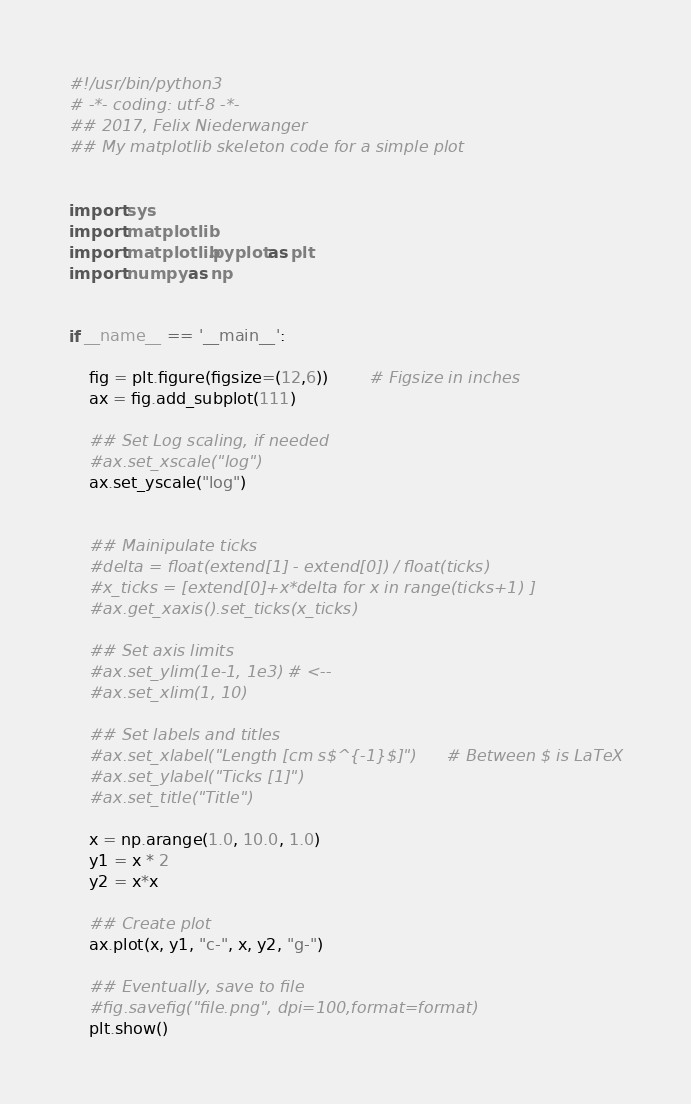<code> <loc_0><loc_0><loc_500><loc_500><_Python_>#!/usr/bin/python3
# -*- coding: utf-8 -*-
## 2017, Felix Niederwanger
## My matplotlib skeleton code for a simple plot


import sys
import matplotlib
import matplotlib.pyplot as plt
import numpy as np


if __name__ == '__main__':
	
	fig = plt.figure(figsize=(12,6))		# Figsize in inches
	ax = fig.add_subplot(111)
	
	## Set Log scaling, if needed
	#ax.set_xscale("log")
	ax.set_yscale("log")
	
	
	## Mainipulate ticks
	#delta = float(extend[1] - extend[0]) / float(ticks)
	#x_ticks = [extend[0]+x*delta for x in range(ticks+1) ]
	#ax.get_xaxis().set_ticks(x_ticks)
	
	## Set axis limits
	#ax.set_ylim(1e-1, 1e3) # <--
	#ax.set_xlim(1, 10)

	## Set labels and titles
	#ax.set_xlabel("Length [cm s$^{-1}$]")		# Between $ is LaTeX
	#ax.set_ylabel("Ticks [1]")
	#ax.set_title("Title")
	
	x = np.arange(1.0, 10.0, 1.0)
	y1 = x * 2
	y2 = x*x
	
	## Create plot
	ax.plot(x, y1, "c-", x, y2, "g-")
	
	## Eventually, save to file
	#fig.savefig("file.png", dpi=100,format=format)
	plt.show()
</code> 